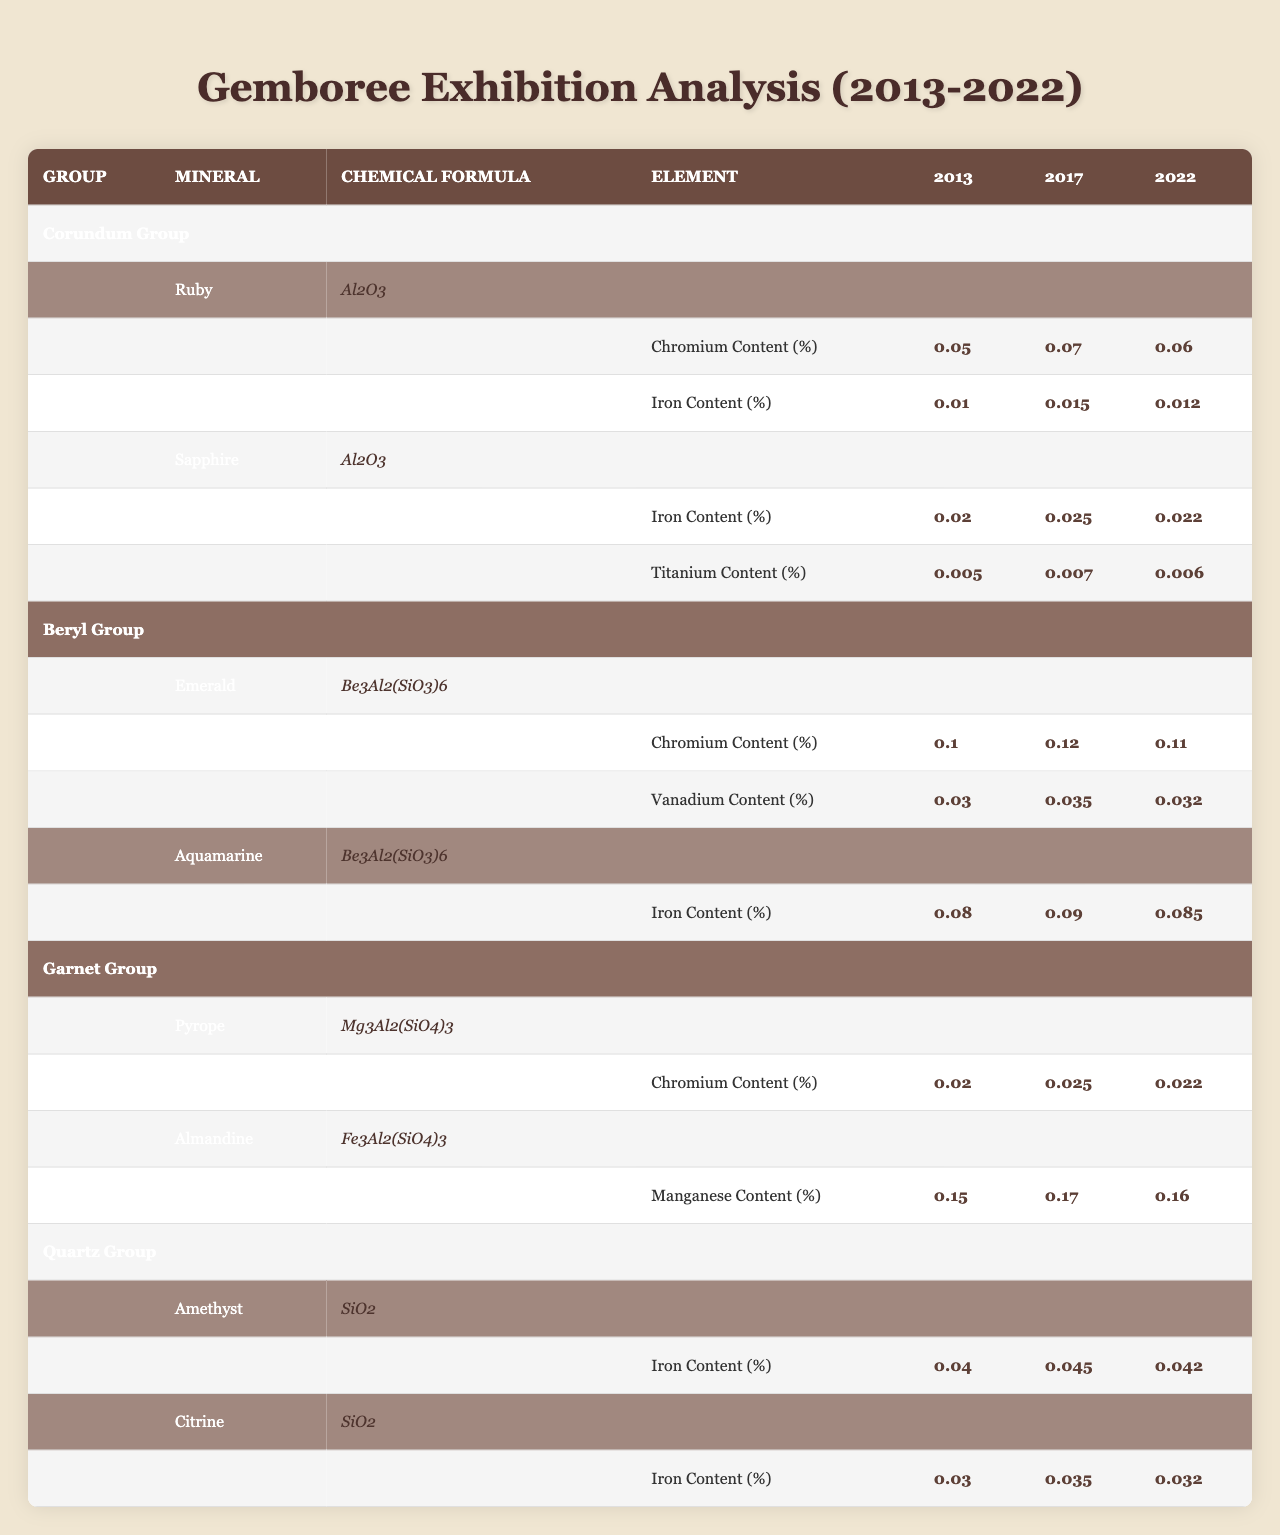What is the chemical formula for Ruby? The table lists the chemical formula for Ruby under the "Corundum Group". It is stated clearly as Al2O3.
Answer: Al2O3 What was the Chromium content in Ruby in 2017? By checking the Ruby section in the "Corundum Group" of the table, the Chromium content for the year 2017 is indicated as 0.07%.
Answer: 0.07% What is the trend of Chromium content in Emerald from 2013 to 2022? To determine the trend, I compare the Chromium content for Emerald across the years: 2013 (0.1%), 2017 (0.12%), and 2022 (0.11%). The content increased from 2013 to 2017, then slightly decreased by 2022.
Answer: Increased then decreased What is the average Iron content in Sapphire over the years? The Iron content values for Sapphire are: 2013 (0.02%), 2017 (0.025%), and 2022 (0.022%). Adding them gives a total of 0.02 + 0.025 + 0.022 = 0.067. Dividing by 3 gives an average of approximately 0.02233%.
Answer: Approximately 0.0223% Did the Iron content in Aquamarine increase from 2013 to 2022? The Iron content in Aquamarine for the years are: 2013 (0.08%), 2017 (0.09%), and 2022 (0.085%). Comparing these values shows that the Iron content increased from 2013 to 2017, but decreased slightly in 2022. Therefore, it did not consistently increase.
Answer: No Which mineral had the highest Manganese content in 2017? Checking the content of Manganese in the Garnet Group, specifically Almandine, in 2017 it is 0.17%. No other minerals in the table list Manganese, indicating that Almandine had the highest Manganese content.
Answer: Almandine What is the difference in Iron content between Amethyst in 2013 and 2022? The Iron content values for Amethyst are 0.04% in 2013 and 0.042% in 2022. Subtracting these values gives 0.042% - 0.04% = 0.002%.
Answer: 0.002% Is there any mineral in the Beryl Group that contains Titanium? Upon reviewing the Beryl Group minerals, only Emerald and Aquamarine are listed, and neither has a Titanium content mentioned. This indicates there is no mineral with Titanium in the Beryl Group.
Answer: No What was the trend for Vanadium content in Emerald from 2013 to 2022? The Vanadium content values for Emerald are: 2013 (0.03%), 2017 (0.035%), and 2022 (0.032%). The trend shows an increase from 2013 to 2017, then a decrease by 2022.
Answer: Increased then decreased Which mineral had the lowest Chromium content in 2022? Reviewing the Chromium contents for 2022: Ruby (0.06%), Emerald (0.11%), Pyrope (0.022%), and Sapphire has no value for Chromium. The lowest is 0.022% from Pyrope.
Answer: Pyrope 